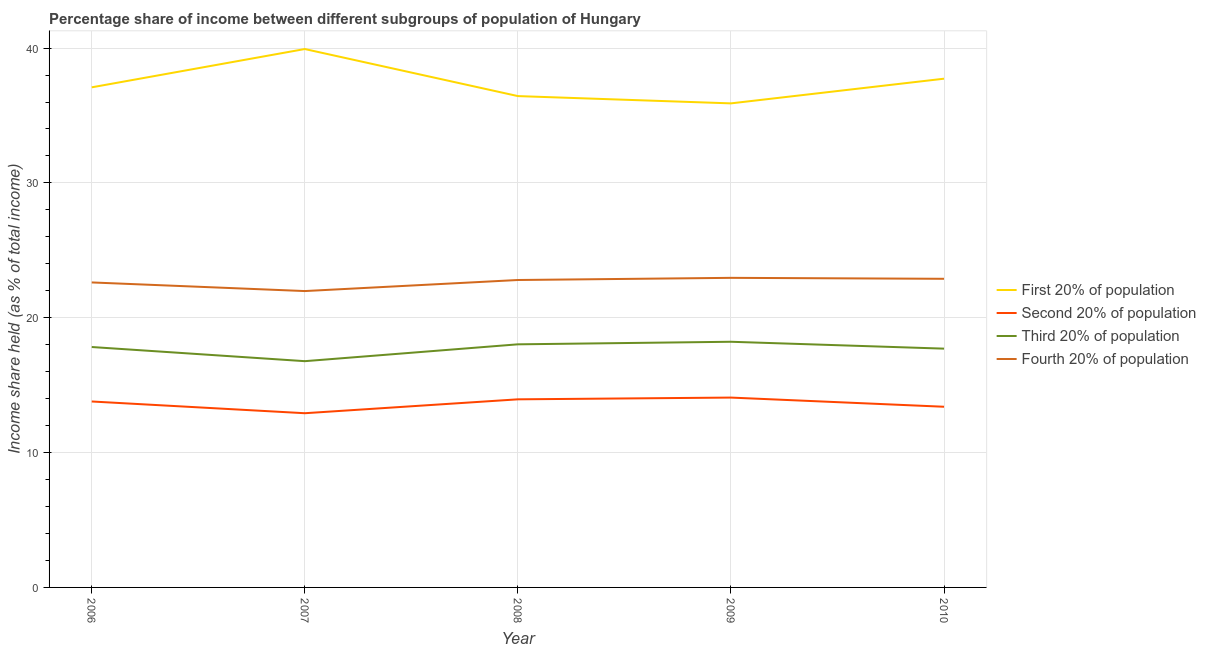How many different coloured lines are there?
Offer a very short reply. 4. What is the share of the income held by first 20% of the population in 2006?
Ensure brevity in your answer.  37.09. Across all years, what is the maximum share of the income held by second 20% of the population?
Your answer should be very brief. 14.08. Across all years, what is the minimum share of the income held by first 20% of the population?
Your response must be concise. 35.9. What is the total share of the income held by second 20% of the population in the graph?
Provide a succinct answer. 68.14. What is the difference between the share of the income held by fourth 20% of the population in 2008 and that in 2010?
Make the answer very short. -0.09. What is the difference between the share of the income held by fourth 20% of the population in 2006 and the share of the income held by second 20% of the population in 2008?
Provide a short and direct response. 8.67. What is the average share of the income held by third 20% of the population per year?
Offer a terse response. 17.71. In the year 2010, what is the difference between the share of the income held by second 20% of the population and share of the income held by fourth 20% of the population?
Ensure brevity in your answer.  -9.49. What is the ratio of the share of the income held by fourth 20% of the population in 2008 to that in 2009?
Provide a succinct answer. 0.99. Is the difference between the share of the income held by fourth 20% of the population in 2006 and 2007 greater than the difference between the share of the income held by second 20% of the population in 2006 and 2007?
Give a very brief answer. No. What is the difference between the highest and the second highest share of the income held by first 20% of the population?
Your answer should be compact. 2.2. What is the difference between the highest and the lowest share of the income held by second 20% of the population?
Give a very brief answer. 1.16. In how many years, is the share of the income held by first 20% of the population greater than the average share of the income held by first 20% of the population taken over all years?
Keep it short and to the point. 2. Is the sum of the share of the income held by second 20% of the population in 2008 and 2009 greater than the maximum share of the income held by first 20% of the population across all years?
Your response must be concise. No. Is it the case that in every year, the sum of the share of the income held by second 20% of the population and share of the income held by third 20% of the population is greater than the sum of share of the income held by first 20% of the population and share of the income held by fourth 20% of the population?
Offer a terse response. Yes. Does the share of the income held by second 20% of the population monotonically increase over the years?
Keep it short and to the point. No. How many lines are there?
Provide a succinct answer. 4. How many years are there in the graph?
Ensure brevity in your answer.  5. Does the graph contain any zero values?
Your answer should be compact. No. Does the graph contain grids?
Keep it short and to the point. Yes. Where does the legend appear in the graph?
Give a very brief answer. Center right. How many legend labels are there?
Provide a short and direct response. 4. What is the title of the graph?
Offer a very short reply. Percentage share of income between different subgroups of population of Hungary. Does "Other expenses" appear as one of the legend labels in the graph?
Offer a very short reply. No. What is the label or title of the X-axis?
Make the answer very short. Year. What is the label or title of the Y-axis?
Offer a very short reply. Income share held (as % of total income). What is the Income share held (as % of total income) in First 20% of population in 2006?
Your answer should be very brief. 37.09. What is the Income share held (as % of total income) of Second 20% of population in 2006?
Your response must be concise. 13.79. What is the Income share held (as % of total income) of Third 20% of population in 2006?
Your answer should be very brief. 17.83. What is the Income share held (as % of total income) of Fourth 20% of population in 2006?
Keep it short and to the point. 22.62. What is the Income share held (as % of total income) of First 20% of population in 2007?
Your answer should be very brief. 39.93. What is the Income share held (as % of total income) in Second 20% of population in 2007?
Give a very brief answer. 12.92. What is the Income share held (as % of total income) of Third 20% of population in 2007?
Provide a succinct answer. 16.78. What is the Income share held (as % of total income) in Fourth 20% of population in 2007?
Offer a very short reply. 21.98. What is the Income share held (as % of total income) of First 20% of population in 2008?
Your answer should be compact. 36.44. What is the Income share held (as % of total income) in Second 20% of population in 2008?
Your answer should be compact. 13.95. What is the Income share held (as % of total income) of Third 20% of population in 2008?
Keep it short and to the point. 18.03. What is the Income share held (as % of total income) in Fourth 20% of population in 2008?
Provide a short and direct response. 22.8. What is the Income share held (as % of total income) in First 20% of population in 2009?
Keep it short and to the point. 35.9. What is the Income share held (as % of total income) of Second 20% of population in 2009?
Keep it short and to the point. 14.08. What is the Income share held (as % of total income) of Third 20% of population in 2009?
Ensure brevity in your answer.  18.22. What is the Income share held (as % of total income) of Fourth 20% of population in 2009?
Give a very brief answer. 22.96. What is the Income share held (as % of total income) of First 20% of population in 2010?
Provide a short and direct response. 37.73. What is the Income share held (as % of total income) in Second 20% of population in 2010?
Provide a short and direct response. 13.4. What is the Income share held (as % of total income) of Third 20% of population in 2010?
Provide a succinct answer. 17.71. What is the Income share held (as % of total income) in Fourth 20% of population in 2010?
Provide a short and direct response. 22.89. Across all years, what is the maximum Income share held (as % of total income) in First 20% of population?
Your response must be concise. 39.93. Across all years, what is the maximum Income share held (as % of total income) in Second 20% of population?
Provide a succinct answer. 14.08. Across all years, what is the maximum Income share held (as % of total income) in Third 20% of population?
Offer a terse response. 18.22. Across all years, what is the maximum Income share held (as % of total income) in Fourth 20% of population?
Keep it short and to the point. 22.96. Across all years, what is the minimum Income share held (as % of total income) of First 20% of population?
Provide a succinct answer. 35.9. Across all years, what is the minimum Income share held (as % of total income) in Second 20% of population?
Make the answer very short. 12.92. Across all years, what is the minimum Income share held (as % of total income) of Third 20% of population?
Offer a very short reply. 16.78. Across all years, what is the minimum Income share held (as % of total income) of Fourth 20% of population?
Provide a short and direct response. 21.98. What is the total Income share held (as % of total income) of First 20% of population in the graph?
Provide a succinct answer. 187.09. What is the total Income share held (as % of total income) in Second 20% of population in the graph?
Provide a short and direct response. 68.14. What is the total Income share held (as % of total income) of Third 20% of population in the graph?
Provide a short and direct response. 88.57. What is the total Income share held (as % of total income) of Fourth 20% of population in the graph?
Offer a very short reply. 113.25. What is the difference between the Income share held (as % of total income) in First 20% of population in 2006 and that in 2007?
Offer a terse response. -2.84. What is the difference between the Income share held (as % of total income) of Second 20% of population in 2006 and that in 2007?
Your response must be concise. 0.87. What is the difference between the Income share held (as % of total income) in Third 20% of population in 2006 and that in 2007?
Your response must be concise. 1.05. What is the difference between the Income share held (as % of total income) in Fourth 20% of population in 2006 and that in 2007?
Offer a very short reply. 0.64. What is the difference between the Income share held (as % of total income) in First 20% of population in 2006 and that in 2008?
Keep it short and to the point. 0.65. What is the difference between the Income share held (as % of total income) of Second 20% of population in 2006 and that in 2008?
Offer a terse response. -0.16. What is the difference between the Income share held (as % of total income) of Fourth 20% of population in 2006 and that in 2008?
Keep it short and to the point. -0.18. What is the difference between the Income share held (as % of total income) in First 20% of population in 2006 and that in 2009?
Make the answer very short. 1.19. What is the difference between the Income share held (as % of total income) of Second 20% of population in 2006 and that in 2009?
Your answer should be very brief. -0.29. What is the difference between the Income share held (as % of total income) of Third 20% of population in 2006 and that in 2009?
Provide a succinct answer. -0.39. What is the difference between the Income share held (as % of total income) of Fourth 20% of population in 2006 and that in 2009?
Provide a succinct answer. -0.34. What is the difference between the Income share held (as % of total income) of First 20% of population in 2006 and that in 2010?
Offer a terse response. -0.64. What is the difference between the Income share held (as % of total income) in Second 20% of population in 2006 and that in 2010?
Offer a very short reply. 0.39. What is the difference between the Income share held (as % of total income) of Third 20% of population in 2006 and that in 2010?
Your answer should be very brief. 0.12. What is the difference between the Income share held (as % of total income) of Fourth 20% of population in 2006 and that in 2010?
Your response must be concise. -0.27. What is the difference between the Income share held (as % of total income) of First 20% of population in 2007 and that in 2008?
Keep it short and to the point. 3.49. What is the difference between the Income share held (as % of total income) of Second 20% of population in 2007 and that in 2008?
Give a very brief answer. -1.03. What is the difference between the Income share held (as % of total income) in Third 20% of population in 2007 and that in 2008?
Your response must be concise. -1.25. What is the difference between the Income share held (as % of total income) in Fourth 20% of population in 2007 and that in 2008?
Provide a succinct answer. -0.82. What is the difference between the Income share held (as % of total income) in First 20% of population in 2007 and that in 2009?
Provide a succinct answer. 4.03. What is the difference between the Income share held (as % of total income) of Second 20% of population in 2007 and that in 2009?
Provide a short and direct response. -1.16. What is the difference between the Income share held (as % of total income) in Third 20% of population in 2007 and that in 2009?
Give a very brief answer. -1.44. What is the difference between the Income share held (as % of total income) of Fourth 20% of population in 2007 and that in 2009?
Ensure brevity in your answer.  -0.98. What is the difference between the Income share held (as % of total income) in First 20% of population in 2007 and that in 2010?
Your answer should be very brief. 2.2. What is the difference between the Income share held (as % of total income) of Second 20% of population in 2007 and that in 2010?
Offer a very short reply. -0.48. What is the difference between the Income share held (as % of total income) of Third 20% of population in 2007 and that in 2010?
Provide a succinct answer. -0.93. What is the difference between the Income share held (as % of total income) of Fourth 20% of population in 2007 and that in 2010?
Your answer should be compact. -0.91. What is the difference between the Income share held (as % of total income) of First 20% of population in 2008 and that in 2009?
Offer a very short reply. 0.54. What is the difference between the Income share held (as % of total income) in Second 20% of population in 2008 and that in 2009?
Offer a very short reply. -0.13. What is the difference between the Income share held (as % of total income) in Third 20% of population in 2008 and that in 2009?
Your answer should be very brief. -0.19. What is the difference between the Income share held (as % of total income) of Fourth 20% of population in 2008 and that in 2009?
Keep it short and to the point. -0.16. What is the difference between the Income share held (as % of total income) of First 20% of population in 2008 and that in 2010?
Make the answer very short. -1.29. What is the difference between the Income share held (as % of total income) in Second 20% of population in 2008 and that in 2010?
Provide a short and direct response. 0.55. What is the difference between the Income share held (as % of total income) in Third 20% of population in 2008 and that in 2010?
Offer a terse response. 0.32. What is the difference between the Income share held (as % of total income) in Fourth 20% of population in 2008 and that in 2010?
Provide a short and direct response. -0.09. What is the difference between the Income share held (as % of total income) of First 20% of population in 2009 and that in 2010?
Make the answer very short. -1.83. What is the difference between the Income share held (as % of total income) in Second 20% of population in 2009 and that in 2010?
Keep it short and to the point. 0.68. What is the difference between the Income share held (as % of total income) of Third 20% of population in 2009 and that in 2010?
Give a very brief answer. 0.51. What is the difference between the Income share held (as % of total income) in Fourth 20% of population in 2009 and that in 2010?
Keep it short and to the point. 0.07. What is the difference between the Income share held (as % of total income) in First 20% of population in 2006 and the Income share held (as % of total income) in Second 20% of population in 2007?
Keep it short and to the point. 24.17. What is the difference between the Income share held (as % of total income) of First 20% of population in 2006 and the Income share held (as % of total income) of Third 20% of population in 2007?
Ensure brevity in your answer.  20.31. What is the difference between the Income share held (as % of total income) in First 20% of population in 2006 and the Income share held (as % of total income) in Fourth 20% of population in 2007?
Your answer should be compact. 15.11. What is the difference between the Income share held (as % of total income) in Second 20% of population in 2006 and the Income share held (as % of total income) in Third 20% of population in 2007?
Your answer should be very brief. -2.99. What is the difference between the Income share held (as % of total income) in Second 20% of population in 2006 and the Income share held (as % of total income) in Fourth 20% of population in 2007?
Keep it short and to the point. -8.19. What is the difference between the Income share held (as % of total income) of Third 20% of population in 2006 and the Income share held (as % of total income) of Fourth 20% of population in 2007?
Your answer should be very brief. -4.15. What is the difference between the Income share held (as % of total income) of First 20% of population in 2006 and the Income share held (as % of total income) of Second 20% of population in 2008?
Ensure brevity in your answer.  23.14. What is the difference between the Income share held (as % of total income) of First 20% of population in 2006 and the Income share held (as % of total income) of Third 20% of population in 2008?
Keep it short and to the point. 19.06. What is the difference between the Income share held (as % of total income) of First 20% of population in 2006 and the Income share held (as % of total income) of Fourth 20% of population in 2008?
Give a very brief answer. 14.29. What is the difference between the Income share held (as % of total income) of Second 20% of population in 2006 and the Income share held (as % of total income) of Third 20% of population in 2008?
Provide a short and direct response. -4.24. What is the difference between the Income share held (as % of total income) in Second 20% of population in 2006 and the Income share held (as % of total income) in Fourth 20% of population in 2008?
Your response must be concise. -9.01. What is the difference between the Income share held (as % of total income) of Third 20% of population in 2006 and the Income share held (as % of total income) of Fourth 20% of population in 2008?
Keep it short and to the point. -4.97. What is the difference between the Income share held (as % of total income) in First 20% of population in 2006 and the Income share held (as % of total income) in Second 20% of population in 2009?
Provide a short and direct response. 23.01. What is the difference between the Income share held (as % of total income) of First 20% of population in 2006 and the Income share held (as % of total income) of Third 20% of population in 2009?
Offer a terse response. 18.87. What is the difference between the Income share held (as % of total income) in First 20% of population in 2006 and the Income share held (as % of total income) in Fourth 20% of population in 2009?
Your answer should be very brief. 14.13. What is the difference between the Income share held (as % of total income) in Second 20% of population in 2006 and the Income share held (as % of total income) in Third 20% of population in 2009?
Your answer should be compact. -4.43. What is the difference between the Income share held (as % of total income) in Second 20% of population in 2006 and the Income share held (as % of total income) in Fourth 20% of population in 2009?
Offer a terse response. -9.17. What is the difference between the Income share held (as % of total income) of Third 20% of population in 2006 and the Income share held (as % of total income) of Fourth 20% of population in 2009?
Provide a short and direct response. -5.13. What is the difference between the Income share held (as % of total income) of First 20% of population in 2006 and the Income share held (as % of total income) of Second 20% of population in 2010?
Make the answer very short. 23.69. What is the difference between the Income share held (as % of total income) of First 20% of population in 2006 and the Income share held (as % of total income) of Third 20% of population in 2010?
Your answer should be very brief. 19.38. What is the difference between the Income share held (as % of total income) in Second 20% of population in 2006 and the Income share held (as % of total income) in Third 20% of population in 2010?
Your response must be concise. -3.92. What is the difference between the Income share held (as % of total income) of Third 20% of population in 2006 and the Income share held (as % of total income) of Fourth 20% of population in 2010?
Keep it short and to the point. -5.06. What is the difference between the Income share held (as % of total income) in First 20% of population in 2007 and the Income share held (as % of total income) in Second 20% of population in 2008?
Your answer should be compact. 25.98. What is the difference between the Income share held (as % of total income) in First 20% of population in 2007 and the Income share held (as % of total income) in Third 20% of population in 2008?
Offer a very short reply. 21.9. What is the difference between the Income share held (as % of total income) in First 20% of population in 2007 and the Income share held (as % of total income) in Fourth 20% of population in 2008?
Keep it short and to the point. 17.13. What is the difference between the Income share held (as % of total income) of Second 20% of population in 2007 and the Income share held (as % of total income) of Third 20% of population in 2008?
Provide a succinct answer. -5.11. What is the difference between the Income share held (as % of total income) in Second 20% of population in 2007 and the Income share held (as % of total income) in Fourth 20% of population in 2008?
Your answer should be compact. -9.88. What is the difference between the Income share held (as % of total income) in Third 20% of population in 2007 and the Income share held (as % of total income) in Fourth 20% of population in 2008?
Offer a very short reply. -6.02. What is the difference between the Income share held (as % of total income) of First 20% of population in 2007 and the Income share held (as % of total income) of Second 20% of population in 2009?
Provide a short and direct response. 25.85. What is the difference between the Income share held (as % of total income) in First 20% of population in 2007 and the Income share held (as % of total income) in Third 20% of population in 2009?
Keep it short and to the point. 21.71. What is the difference between the Income share held (as % of total income) of First 20% of population in 2007 and the Income share held (as % of total income) of Fourth 20% of population in 2009?
Your response must be concise. 16.97. What is the difference between the Income share held (as % of total income) in Second 20% of population in 2007 and the Income share held (as % of total income) in Third 20% of population in 2009?
Your answer should be compact. -5.3. What is the difference between the Income share held (as % of total income) in Second 20% of population in 2007 and the Income share held (as % of total income) in Fourth 20% of population in 2009?
Keep it short and to the point. -10.04. What is the difference between the Income share held (as % of total income) in Third 20% of population in 2007 and the Income share held (as % of total income) in Fourth 20% of population in 2009?
Your answer should be compact. -6.18. What is the difference between the Income share held (as % of total income) in First 20% of population in 2007 and the Income share held (as % of total income) in Second 20% of population in 2010?
Provide a succinct answer. 26.53. What is the difference between the Income share held (as % of total income) in First 20% of population in 2007 and the Income share held (as % of total income) in Third 20% of population in 2010?
Provide a short and direct response. 22.22. What is the difference between the Income share held (as % of total income) of First 20% of population in 2007 and the Income share held (as % of total income) of Fourth 20% of population in 2010?
Your response must be concise. 17.04. What is the difference between the Income share held (as % of total income) of Second 20% of population in 2007 and the Income share held (as % of total income) of Third 20% of population in 2010?
Offer a terse response. -4.79. What is the difference between the Income share held (as % of total income) of Second 20% of population in 2007 and the Income share held (as % of total income) of Fourth 20% of population in 2010?
Ensure brevity in your answer.  -9.97. What is the difference between the Income share held (as % of total income) in Third 20% of population in 2007 and the Income share held (as % of total income) in Fourth 20% of population in 2010?
Your answer should be compact. -6.11. What is the difference between the Income share held (as % of total income) of First 20% of population in 2008 and the Income share held (as % of total income) of Second 20% of population in 2009?
Your answer should be compact. 22.36. What is the difference between the Income share held (as % of total income) in First 20% of population in 2008 and the Income share held (as % of total income) in Third 20% of population in 2009?
Your answer should be very brief. 18.22. What is the difference between the Income share held (as % of total income) of First 20% of population in 2008 and the Income share held (as % of total income) of Fourth 20% of population in 2009?
Your answer should be very brief. 13.48. What is the difference between the Income share held (as % of total income) of Second 20% of population in 2008 and the Income share held (as % of total income) of Third 20% of population in 2009?
Ensure brevity in your answer.  -4.27. What is the difference between the Income share held (as % of total income) of Second 20% of population in 2008 and the Income share held (as % of total income) of Fourth 20% of population in 2009?
Offer a very short reply. -9.01. What is the difference between the Income share held (as % of total income) in Third 20% of population in 2008 and the Income share held (as % of total income) in Fourth 20% of population in 2009?
Ensure brevity in your answer.  -4.93. What is the difference between the Income share held (as % of total income) in First 20% of population in 2008 and the Income share held (as % of total income) in Second 20% of population in 2010?
Your response must be concise. 23.04. What is the difference between the Income share held (as % of total income) of First 20% of population in 2008 and the Income share held (as % of total income) of Third 20% of population in 2010?
Offer a very short reply. 18.73. What is the difference between the Income share held (as % of total income) of First 20% of population in 2008 and the Income share held (as % of total income) of Fourth 20% of population in 2010?
Keep it short and to the point. 13.55. What is the difference between the Income share held (as % of total income) of Second 20% of population in 2008 and the Income share held (as % of total income) of Third 20% of population in 2010?
Your answer should be very brief. -3.76. What is the difference between the Income share held (as % of total income) of Second 20% of population in 2008 and the Income share held (as % of total income) of Fourth 20% of population in 2010?
Your answer should be very brief. -8.94. What is the difference between the Income share held (as % of total income) in Third 20% of population in 2008 and the Income share held (as % of total income) in Fourth 20% of population in 2010?
Offer a terse response. -4.86. What is the difference between the Income share held (as % of total income) in First 20% of population in 2009 and the Income share held (as % of total income) in Third 20% of population in 2010?
Offer a very short reply. 18.19. What is the difference between the Income share held (as % of total income) in First 20% of population in 2009 and the Income share held (as % of total income) in Fourth 20% of population in 2010?
Ensure brevity in your answer.  13.01. What is the difference between the Income share held (as % of total income) in Second 20% of population in 2009 and the Income share held (as % of total income) in Third 20% of population in 2010?
Your response must be concise. -3.63. What is the difference between the Income share held (as % of total income) in Second 20% of population in 2009 and the Income share held (as % of total income) in Fourth 20% of population in 2010?
Ensure brevity in your answer.  -8.81. What is the difference between the Income share held (as % of total income) in Third 20% of population in 2009 and the Income share held (as % of total income) in Fourth 20% of population in 2010?
Your response must be concise. -4.67. What is the average Income share held (as % of total income) in First 20% of population per year?
Offer a terse response. 37.42. What is the average Income share held (as % of total income) of Second 20% of population per year?
Provide a short and direct response. 13.63. What is the average Income share held (as % of total income) in Third 20% of population per year?
Your response must be concise. 17.71. What is the average Income share held (as % of total income) of Fourth 20% of population per year?
Give a very brief answer. 22.65. In the year 2006, what is the difference between the Income share held (as % of total income) of First 20% of population and Income share held (as % of total income) of Second 20% of population?
Your response must be concise. 23.3. In the year 2006, what is the difference between the Income share held (as % of total income) of First 20% of population and Income share held (as % of total income) of Third 20% of population?
Your answer should be compact. 19.26. In the year 2006, what is the difference between the Income share held (as % of total income) of First 20% of population and Income share held (as % of total income) of Fourth 20% of population?
Make the answer very short. 14.47. In the year 2006, what is the difference between the Income share held (as % of total income) in Second 20% of population and Income share held (as % of total income) in Third 20% of population?
Keep it short and to the point. -4.04. In the year 2006, what is the difference between the Income share held (as % of total income) of Second 20% of population and Income share held (as % of total income) of Fourth 20% of population?
Provide a short and direct response. -8.83. In the year 2006, what is the difference between the Income share held (as % of total income) in Third 20% of population and Income share held (as % of total income) in Fourth 20% of population?
Provide a short and direct response. -4.79. In the year 2007, what is the difference between the Income share held (as % of total income) of First 20% of population and Income share held (as % of total income) of Second 20% of population?
Your answer should be very brief. 27.01. In the year 2007, what is the difference between the Income share held (as % of total income) of First 20% of population and Income share held (as % of total income) of Third 20% of population?
Offer a very short reply. 23.15. In the year 2007, what is the difference between the Income share held (as % of total income) of First 20% of population and Income share held (as % of total income) of Fourth 20% of population?
Ensure brevity in your answer.  17.95. In the year 2007, what is the difference between the Income share held (as % of total income) of Second 20% of population and Income share held (as % of total income) of Third 20% of population?
Offer a terse response. -3.86. In the year 2007, what is the difference between the Income share held (as % of total income) in Second 20% of population and Income share held (as % of total income) in Fourth 20% of population?
Offer a terse response. -9.06. In the year 2008, what is the difference between the Income share held (as % of total income) of First 20% of population and Income share held (as % of total income) of Second 20% of population?
Give a very brief answer. 22.49. In the year 2008, what is the difference between the Income share held (as % of total income) of First 20% of population and Income share held (as % of total income) of Third 20% of population?
Your answer should be compact. 18.41. In the year 2008, what is the difference between the Income share held (as % of total income) of First 20% of population and Income share held (as % of total income) of Fourth 20% of population?
Make the answer very short. 13.64. In the year 2008, what is the difference between the Income share held (as % of total income) in Second 20% of population and Income share held (as % of total income) in Third 20% of population?
Offer a terse response. -4.08. In the year 2008, what is the difference between the Income share held (as % of total income) of Second 20% of population and Income share held (as % of total income) of Fourth 20% of population?
Make the answer very short. -8.85. In the year 2008, what is the difference between the Income share held (as % of total income) in Third 20% of population and Income share held (as % of total income) in Fourth 20% of population?
Give a very brief answer. -4.77. In the year 2009, what is the difference between the Income share held (as % of total income) of First 20% of population and Income share held (as % of total income) of Second 20% of population?
Provide a succinct answer. 21.82. In the year 2009, what is the difference between the Income share held (as % of total income) of First 20% of population and Income share held (as % of total income) of Third 20% of population?
Offer a very short reply. 17.68. In the year 2009, what is the difference between the Income share held (as % of total income) in First 20% of population and Income share held (as % of total income) in Fourth 20% of population?
Your answer should be compact. 12.94. In the year 2009, what is the difference between the Income share held (as % of total income) of Second 20% of population and Income share held (as % of total income) of Third 20% of population?
Offer a terse response. -4.14. In the year 2009, what is the difference between the Income share held (as % of total income) in Second 20% of population and Income share held (as % of total income) in Fourth 20% of population?
Provide a succinct answer. -8.88. In the year 2009, what is the difference between the Income share held (as % of total income) in Third 20% of population and Income share held (as % of total income) in Fourth 20% of population?
Give a very brief answer. -4.74. In the year 2010, what is the difference between the Income share held (as % of total income) of First 20% of population and Income share held (as % of total income) of Second 20% of population?
Your answer should be very brief. 24.33. In the year 2010, what is the difference between the Income share held (as % of total income) of First 20% of population and Income share held (as % of total income) of Third 20% of population?
Your answer should be very brief. 20.02. In the year 2010, what is the difference between the Income share held (as % of total income) in First 20% of population and Income share held (as % of total income) in Fourth 20% of population?
Offer a terse response. 14.84. In the year 2010, what is the difference between the Income share held (as % of total income) in Second 20% of population and Income share held (as % of total income) in Third 20% of population?
Provide a short and direct response. -4.31. In the year 2010, what is the difference between the Income share held (as % of total income) in Second 20% of population and Income share held (as % of total income) in Fourth 20% of population?
Offer a terse response. -9.49. In the year 2010, what is the difference between the Income share held (as % of total income) in Third 20% of population and Income share held (as % of total income) in Fourth 20% of population?
Provide a succinct answer. -5.18. What is the ratio of the Income share held (as % of total income) of First 20% of population in 2006 to that in 2007?
Provide a short and direct response. 0.93. What is the ratio of the Income share held (as % of total income) of Second 20% of population in 2006 to that in 2007?
Keep it short and to the point. 1.07. What is the ratio of the Income share held (as % of total income) of Third 20% of population in 2006 to that in 2007?
Keep it short and to the point. 1.06. What is the ratio of the Income share held (as % of total income) in Fourth 20% of population in 2006 to that in 2007?
Offer a very short reply. 1.03. What is the ratio of the Income share held (as % of total income) of First 20% of population in 2006 to that in 2008?
Offer a very short reply. 1.02. What is the ratio of the Income share held (as % of total income) in Second 20% of population in 2006 to that in 2008?
Provide a short and direct response. 0.99. What is the ratio of the Income share held (as % of total income) of Third 20% of population in 2006 to that in 2008?
Provide a short and direct response. 0.99. What is the ratio of the Income share held (as % of total income) in First 20% of population in 2006 to that in 2009?
Keep it short and to the point. 1.03. What is the ratio of the Income share held (as % of total income) in Second 20% of population in 2006 to that in 2009?
Offer a terse response. 0.98. What is the ratio of the Income share held (as % of total income) of Third 20% of population in 2006 to that in 2009?
Your answer should be very brief. 0.98. What is the ratio of the Income share held (as % of total income) in Fourth 20% of population in 2006 to that in 2009?
Offer a very short reply. 0.99. What is the ratio of the Income share held (as % of total income) in First 20% of population in 2006 to that in 2010?
Offer a very short reply. 0.98. What is the ratio of the Income share held (as % of total income) of Second 20% of population in 2006 to that in 2010?
Give a very brief answer. 1.03. What is the ratio of the Income share held (as % of total income) in Third 20% of population in 2006 to that in 2010?
Offer a terse response. 1.01. What is the ratio of the Income share held (as % of total income) in Fourth 20% of population in 2006 to that in 2010?
Ensure brevity in your answer.  0.99. What is the ratio of the Income share held (as % of total income) in First 20% of population in 2007 to that in 2008?
Provide a succinct answer. 1.1. What is the ratio of the Income share held (as % of total income) in Second 20% of population in 2007 to that in 2008?
Keep it short and to the point. 0.93. What is the ratio of the Income share held (as % of total income) in Third 20% of population in 2007 to that in 2008?
Your answer should be very brief. 0.93. What is the ratio of the Income share held (as % of total income) in Fourth 20% of population in 2007 to that in 2008?
Provide a succinct answer. 0.96. What is the ratio of the Income share held (as % of total income) in First 20% of population in 2007 to that in 2009?
Your answer should be compact. 1.11. What is the ratio of the Income share held (as % of total income) of Second 20% of population in 2007 to that in 2009?
Make the answer very short. 0.92. What is the ratio of the Income share held (as % of total income) of Third 20% of population in 2007 to that in 2009?
Provide a succinct answer. 0.92. What is the ratio of the Income share held (as % of total income) in Fourth 20% of population in 2007 to that in 2009?
Provide a short and direct response. 0.96. What is the ratio of the Income share held (as % of total income) of First 20% of population in 2007 to that in 2010?
Keep it short and to the point. 1.06. What is the ratio of the Income share held (as % of total income) of Second 20% of population in 2007 to that in 2010?
Offer a very short reply. 0.96. What is the ratio of the Income share held (as % of total income) of Third 20% of population in 2007 to that in 2010?
Ensure brevity in your answer.  0.95. What is the ratio of the Income share held (as % of total income) in Fourth 20% of population in 2007 to that in 2010?
Provide a succinct answer. 0.96. What is the ratio of the Income share held (as % of total income) in First 20% of population in 2008 to that in 2009?
Offer a very short reply. 1.01. What is the ratio of the Income share held (as % of total income) of Second 20% of population in 2008 to that in 2009?
Ensure brevity in your answer.  0.99. What is the ratio of the Income share held (as % of total income) of Third 20% of population in 2008 to that in 2009?
Keep it short and to the point. 0.99. What is the ratio of the Income share held (as % of total income) in Fourth 20% of population in 2008 to that in 2009?
Offer a terse response. 0.99. What is the ratio of the Income share held (as % of total income) of First 20% of population in 2008 to that in 2010?
Your answer should be compact. 0.97. What is the ratio of the Income share held (as % of total income) of Second 20% of population in 2008 to that in 2010?
Offer a terse response. 1.04. What is the ratio of the Income share held (as % of total income) of Third 20% of population in 2008 to that in 2010?
Make the answer very short. 1.02. What is the ratio of the Income share held (as % of total income) of First 20% of population in 2009 to that in 2010?
Your answer should be very brief. 0.95. What is the ratio of the Income share held (as % of total income) in Second 20% of population in 2009 to that in 2010?
Make the answer very short. 1.05. What is the ratio of the Income share held (as % of total income) in Third 20% of population in 2009 to that in 2010?
Ensure brevity in your answer.  1.03. What is the ratio of the Income share held (as % of total income) of Fourth 20% of population in 2009 to that in 2010?
Your response must be concise. 1. What is the difference between the highest and the second highest Income share held (as % of total income) of Second 20% of population?
Your answer should be compact. 0.13. What is the difference between the highest and the second highest Income share held (as % of total income) in Third 20% of population?
Provide a succinct answer. 0.19. What is the difference between the highest and the second highest Income share held (as % of total income) of Fourth 20% of population?
Offer a terse response. 0.07. What is the difference between the highest and the lowest Income share held (as % of total income) of First 20% of population?
Keep it short and to the point. 4.03. What is the difference between the highest and the lowest Income share held (as % of total income) in Second 20% of population?
Provide a succinct answer. 1.16. What is the difference between the highest and the lowest Income share held (as % of total income) of Third 20% of population?
Provide a succinct answer. 1.44. 